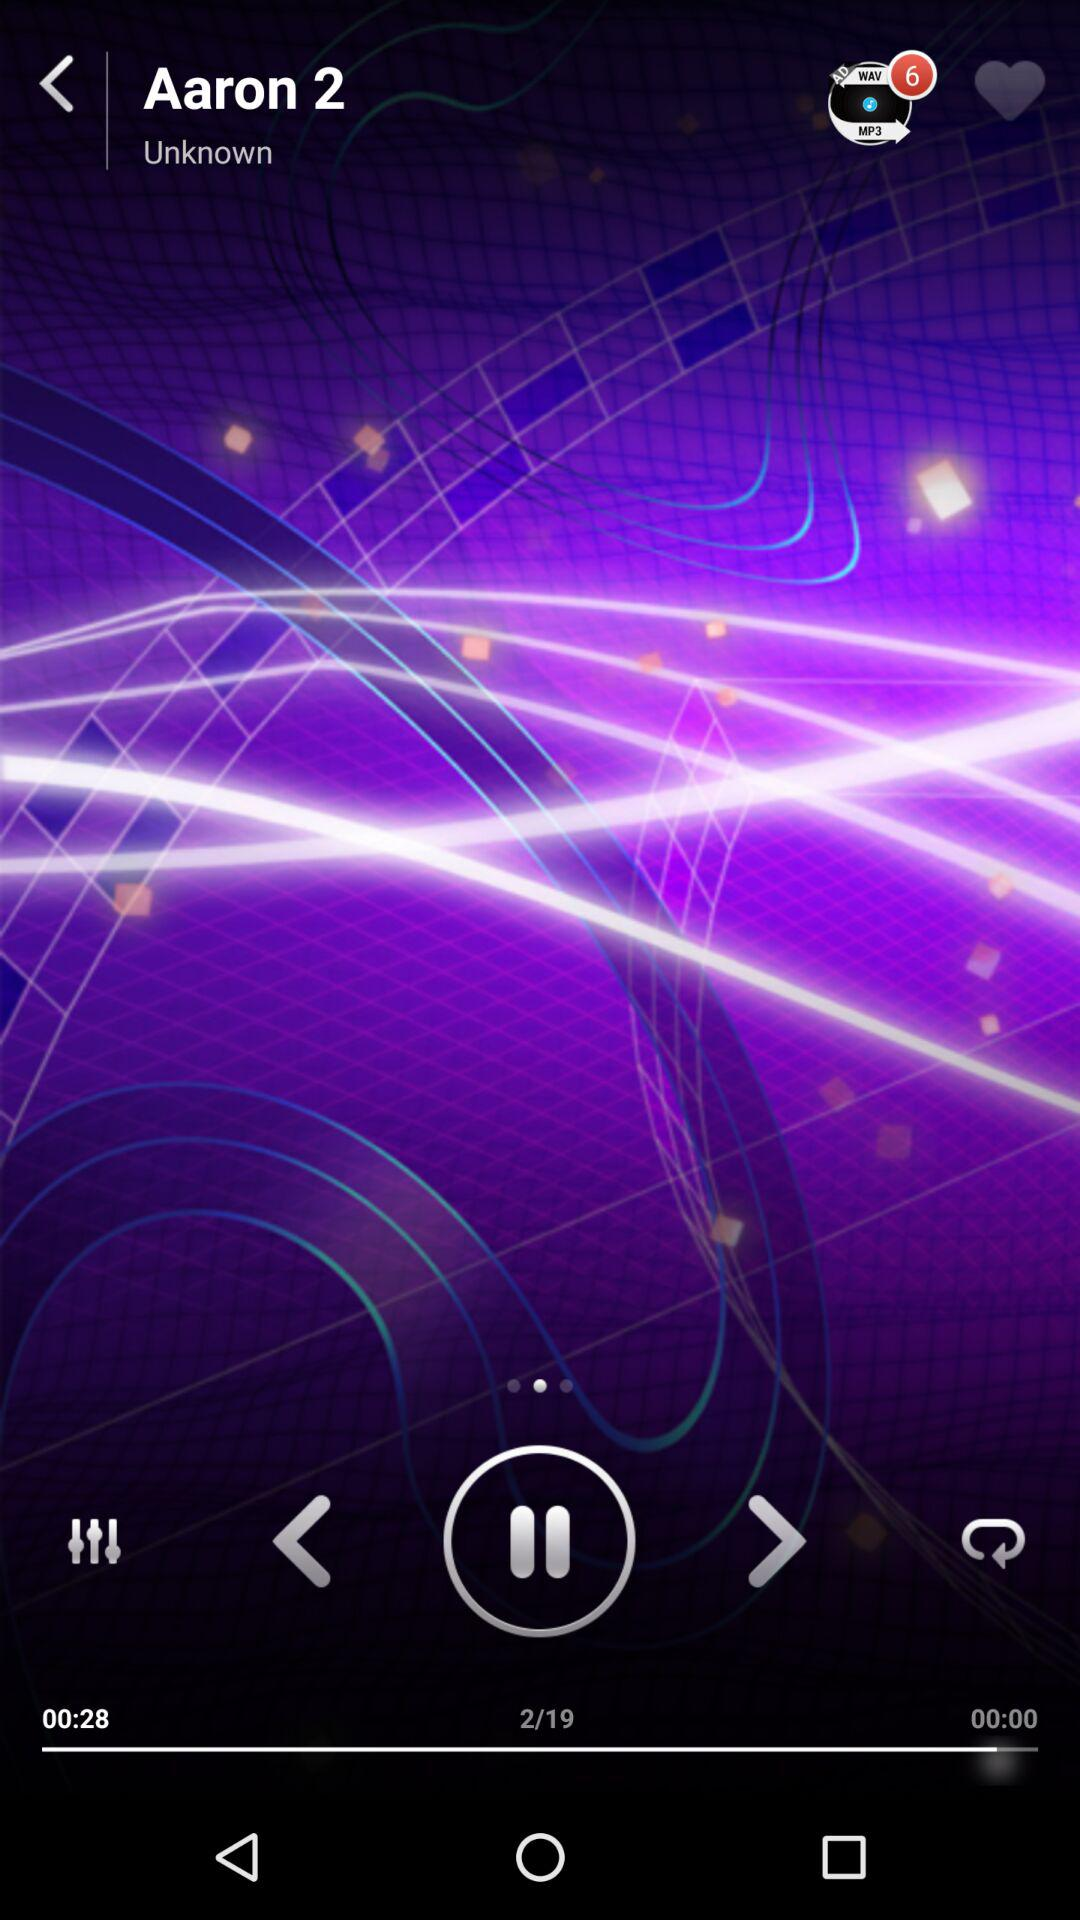Which song number is currently playing? The song number is 2. 